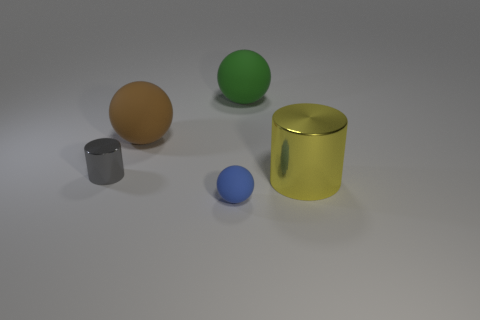Add 2 brown things. How many objects exist? 7 Subtract all cylinders. How many objects are left? 3 Add 2 large purple rubber balls. How many large purple rubber balls exist? 2 Subtract 0 purple balls. How many objects are left? 5 Subtract all green things. Subtract all tiny matte things. How many objects are left? 3 Add 3 big yellow shiny things. How many big yellow shiny things are left? 4 